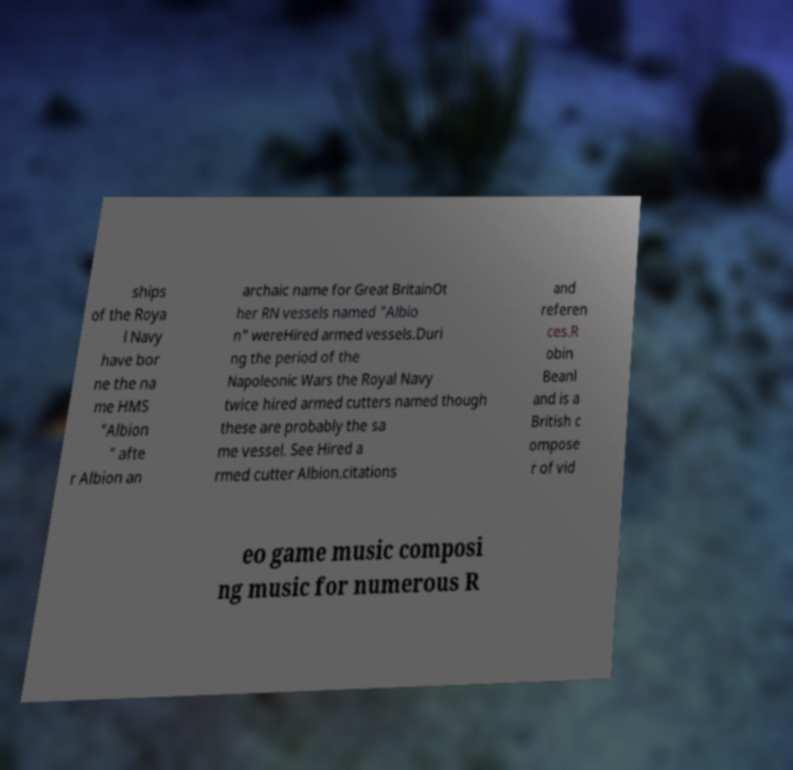Can you accurately transcribe the text from the provided image for me? ships of the Roya l Navy have bor ne the na me HMS "Albion " afte r Albion an archaic name for Great BritainOt her RN vessels named "Albio n" wereHired armed vessels.Duri ng the period of the Napoleonic Wars the Royal Navy twice hired armed cutters named though these are probably the sa me vessel. See Hired a rmed cutter Albion.citations and referen ces.R obin Beanl and is a British c ompose r of vid eo game music composi ng music for numerous R 